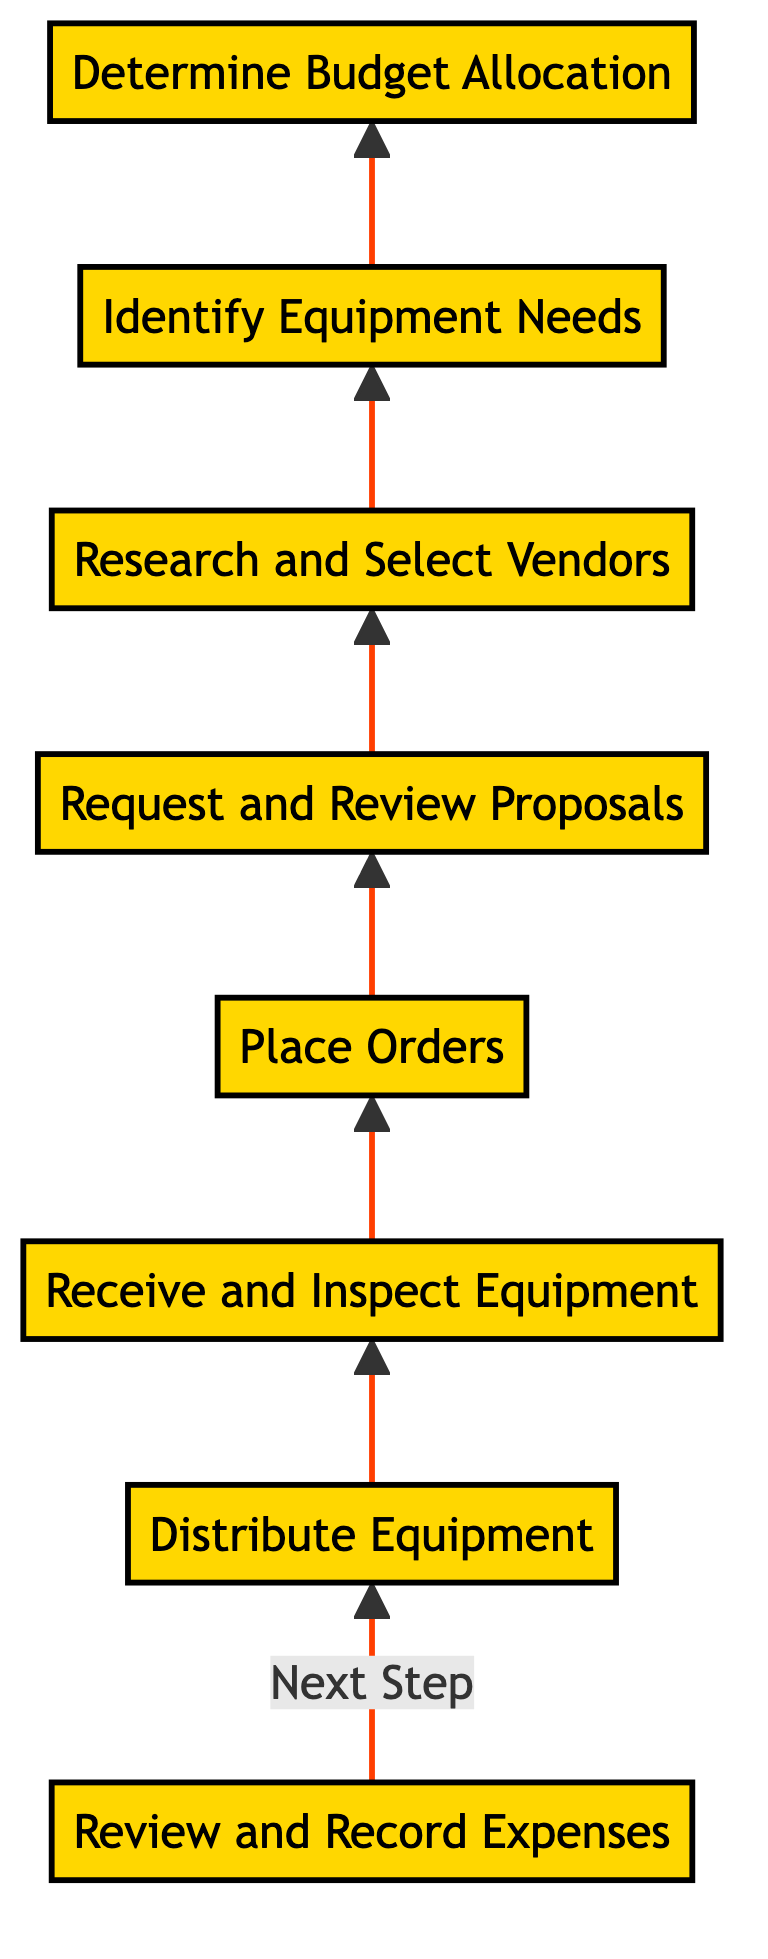What is the first step in the flow chart? The first step in the flow chart is to determine the budget allocation, which involves assessing available funds for golf equipment for the school year.
Answer: Determine Budget Allocation How many steps are in the flow chart? There are a total of eight steps in the flow chart, which represent the process of golf equipment procurement from budget allocation to final distribution.
Answer: Eight What is the last step before distributing equipment? The last step before distributing equipment is receiving and inspecting the equipment to ensure there are no discrepancies or defects.
Answer: Receive and Inspect Equipment What activity involves negotiating final prices? The activity that involves negotiating final prices occurs during the place orders step, where final prices and delivery terms are discussed and confirmed with selected vendors.
Answer: Place Orders Which step follows researching and selecting vendors? The step that follows researching and selecting vendors is requesting and reviewing proposals from potential suppliers where bids are collected and assessed.
Answer: Request and Review Proposals What does each step in the flow chart represent? Each step in the flow chart represents an action or stage in the golf equipment procurement process, outlining the progression from the initial budget allocation to the final distribution of equipment.
Answer: An action or stage How is the flow of the chart structured? The flow of the chart is structured in a bottom-to-top direction, indicating the sequential order of steps beginning with budget allocation and culminating in expense review.
Answer: Bottom-to-top What document is created during the request and review proposals step? During the request and review proposals step, a formal request for proposal (RFP) is created to gather bids from potential suppliers.
Answer: Request for proposal What is the main focus when reviewing proposals? The main focus when reviewing proposals is on assessing quality and cost to ensure the best value for the golf equipment procurement process.
Answer: Quality and cost 